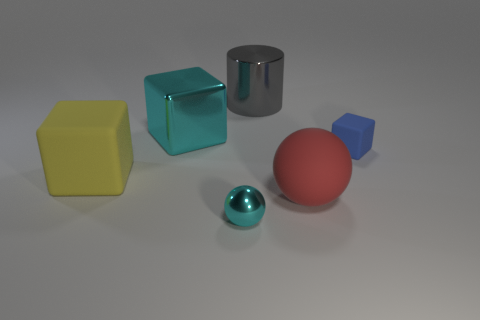Add 1 tiny blue metallic cylinders. How many objects exist? 7 Subtract all spheres. How many objects are left? 4 Add 3 small blue blocks. How many small blue blocks exist? 4 Subtract 0 gray cubes. How many objects are left? 6 Subtract all big cyan cylinders. Subtract all yellow blocks. How many objects are left? 5 Add 5 yellow cubes. How many yellow cubes are left? 6 